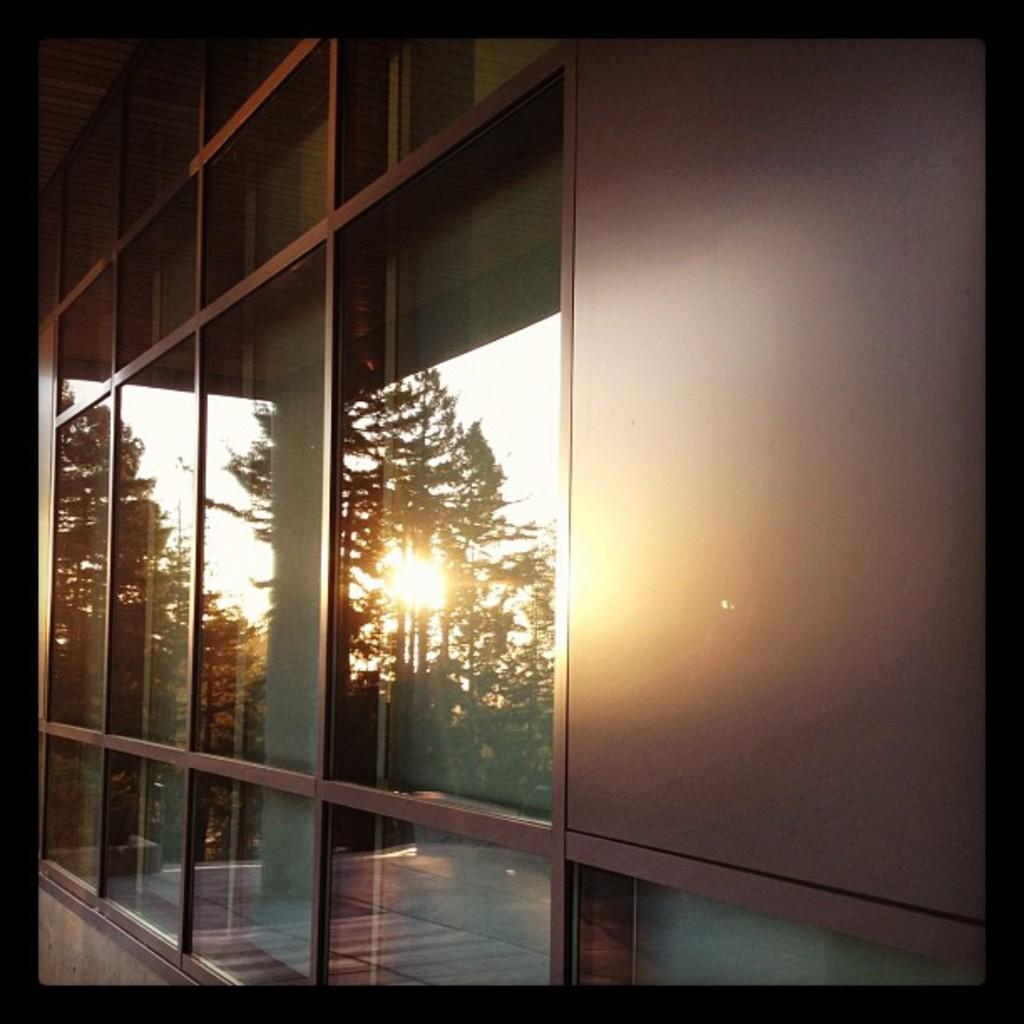In one or two sentences, can you explain what this image depicts? In the picture we can see a building wall with a glass in it and on it we can see an image of trees and sun. 